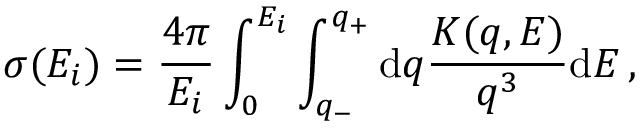<formula> <loc_0><loc_0><loc_500><loc_500>\sigma { ( E _ { i } ) } = \frac { 4 \pi } { E _ { i } } \int _ { 0 } ^ { E _ { i } } \int _ { q _ { - } } ^ { q _ { + } } d q \frac { K { ( q , E ) } } { q ^ { 3 } } d E \, ,</formula> 